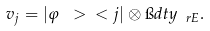<formula> <loc_0><loc_0><loc_500><loc_500>v _ { j } = | \varphi \ > \ < j | \otimes \i d t y _ { \ r E } .</formula> 